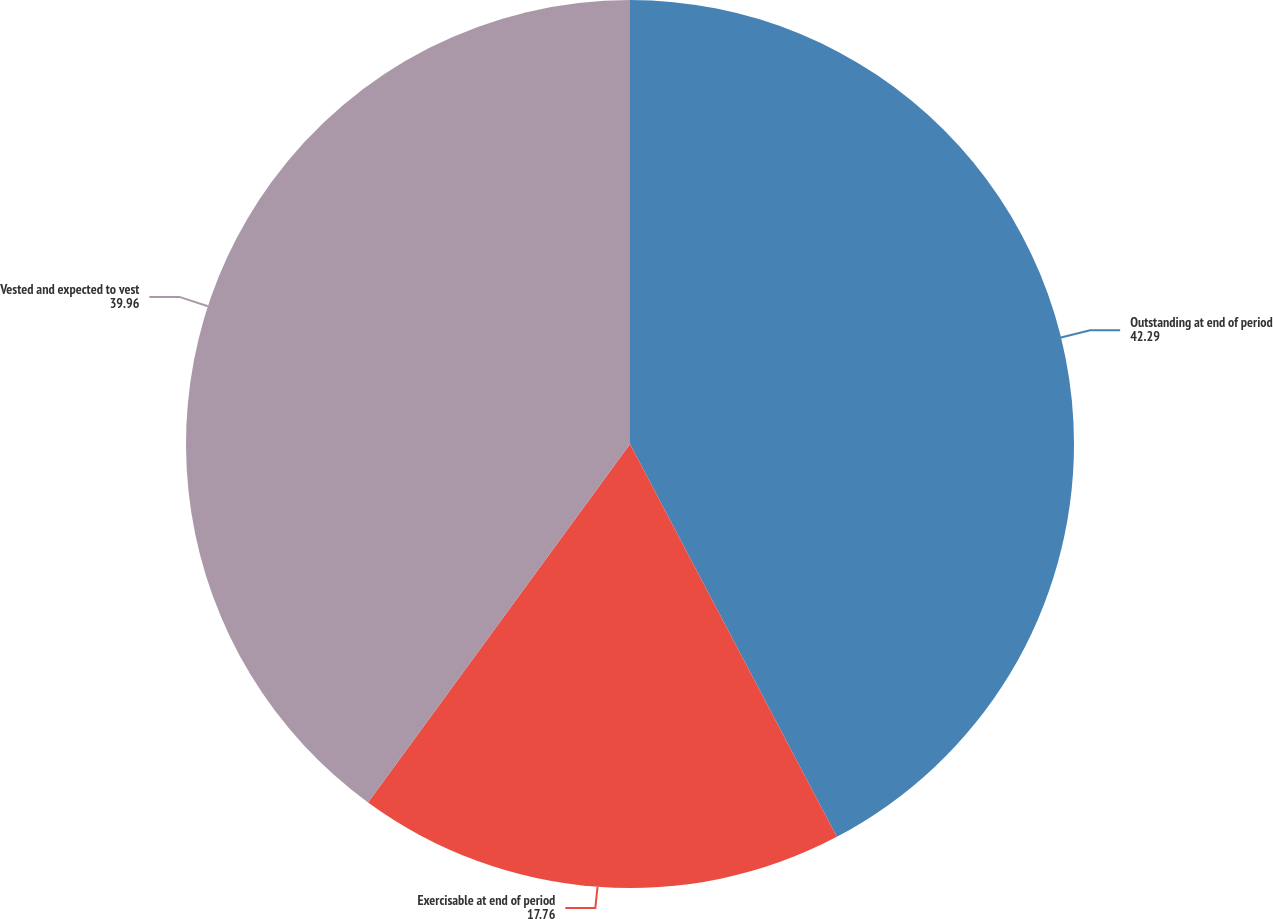Convert chart to OTSL. <chart><loc_0><loc_0><loc_500><loc_500><pie_chart><fcel>Outstanding at end of period<fcel>Exercisable at end of period<fcel>Vested and expected to vest<nl><fcel>42.29%<fcel>17.76%<fcel>39.96%<nl></chart> 